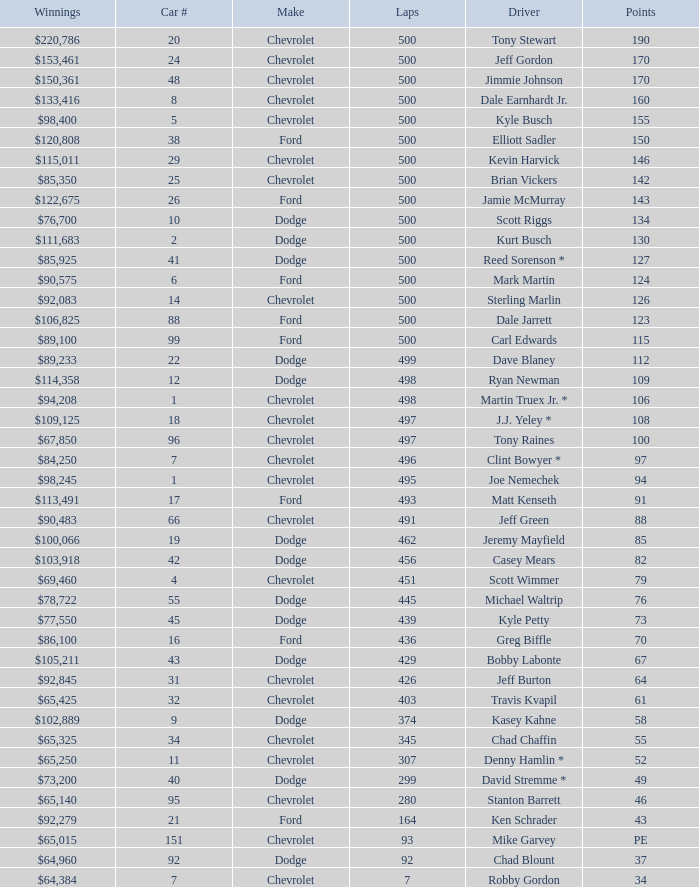What is the average car number of all the drivers with 109 points? 12.0. Can you give me this table as a dict? {'header': ['Winnings', 'Car #', 'Make', 'Laps', 'Driver', 'Points'], 'rows': [['$220,786', '20', 'Chevrolet', '500', 'Tony Stewart', '190'], ['$153,461', '24', 'Chevrolet', '500', 'Jeff Gordon', '170'], ['$150,361', '48', 'Chevrolet', '500', 'Jimmie Johnson', '170'], ['$133,416', '8', 'Chevrolet', '500', 'Dale Earnhardt Jr.', '160'], ['$98,400', '5', 'Chevrolet', '500', 'Kyle Busch', '155'], ['$120,808', '38', 'Ford', '500', 'Elliott Sadler', '150'], ['$115,011', '29', 'Chevrolet', '500', 'Kevin Harvick', '146'], ['$85,350', '25', 'Chevrolet', '500', 'Brian Vickers', '142'], ['$122,675', '26', 'Ford', '500', 'Jamie McMurray', '143'], ['$76,700', '10', 'Dodge', '500', 'Scott Riggs', '134'], ['$111,683', '2', 'Dodge', '500', 'Kurt Busch', '130'], ['$85,925', '41', 'Dodge', '500', 'Reed Sorenson *', '127'], ['$90,575', '6', 'Ford', '500', 'Mark Martin', '124'], ['$92,083', '14', 'Chevrolet', '500', 'Sterling Marlin', '126'], ['$106,825', '88', 'Ford', '500', 'Dale Jarrett', '123'], ['$89,100', '99', 'Ford', '500', 'Carl Edwards', '115'], ['$89,233', '22', 'Dodge', '499', 'Dave Blaney', '112'], ['$114,358', '12', 'Dodge', '498', 'Ryan Newman', '109'], ['$94,208', '1', 'Chevrolet', '498', 'Martin Truex Jr. *', '106'], ['$109,125', '18', 'Chevrolet', '497', 'J.J. Yeley *', '108'], ['$67,850', '96', 'Chevrolet', '497', 'Tony Raines', '100'], ['$84,250', '7', 'Chevrolet', '496', 'Clint Bowyer *', '97'], ['$98,245', '1', 'Chevrolet', '495', 'Joe Nemechek', '94'], ['$113,491', '17', 'Ford', '493', 'Matt Kenseth', '91'], ['$90,483', '66', 'Chevrolet', '491', 'Jeff Green', '88'], ['$100,066', '19', 'Dodge', '462', 'Jeremy Mayfield', '85'], ['$103,918', '42', 'Dodge', '456', 'Casey Mears', '82'], ['$69,460', '4', 'Chevrolet', '451', 'Scott Wimmer', '79'], ['$78,722', '55', 'Dodge', '445', 'Michael Waltrip', '76'], ['$77,550', '45', 'Dodge', '439', 'Kyle Petty', '73'], ['$86,100', '16', 'Ford', '436', 'Greg Biffle', '70'], ['$105,211', '43', 'Dodge', '429', 'Bobby Labonte', '67'], ['$92,845', '31', 'Chevrolet', '426', 'Jeff Burton', '64'], ['$65,425', '32', 'Chevrolet', '403', 'Travis Kvapil', '61'], ['$102,889', '9', 'Dodge', '374', 'Kasey Kahne', '58'], ['$65,325', '34', 'Chevrolet', '345', 'Chad Chaffin', '55'], ['$65,250', '11', 'Chevrolet', '307', 'Denny Hamlin *', '52'], ['$73,200', '40', 'Dodge', '299', 'David Stremme *', '49'], ['$65,140', '95', 'Chevrolet', '280', 'Stanton Barrett', '46'], ['$92,279', '21', 'Ford', '164', 'Ken Schrader', '43'], ['$65,015', '151', 'Chevrolet', '93', 'Mike Garvey', 'PE'], ['$64,960', '92', 'Dodge', '92', 'Chad Blount', '37'], ['$64,384', '7', 'Chevrolet', '7', 'Robby Gordon', '34']]} 